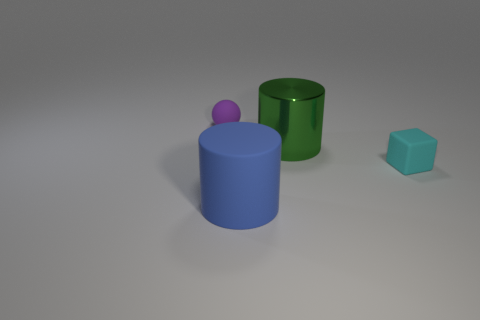Subtract all spheres. How many objects are left? 3 Subtract 1 cylinders. How many cylinders are left? 1 Add 1 cyan matte objects. How many objects exist? 5 Subtract all blue balls. Subtract all red blocks. How many balls are left? 1 Subtract all cyan cylinders. How many yellow spheres are left? 0 Subtract all cylinders. Subtract all cyan matte cubes. How many objects are left? 1 Add 3 big blue matte objects. How many big blue matte objects are left? 4 Add 4 matte cylinders. How many matte cylinders exist? 5 Subtract all green cylinders. How many cylinders are left? 1 Subtract 1 green cylinders. How many objects are left? 3 